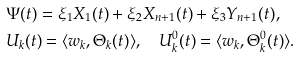Convert formula to latex. <formula><loc_0><loc_0><loc_500><loc_500>& \Psi ( t ) = \xi _ { 1 } X _ { 1 } ( t ) + \xi _ { 2 } X _ { n + 1 } ( t ) + \xi _ { 3 } Y _ { n + 1 } ( t ) , \\ & U _ { k } ( t ) = \langle w _ { k } , \Theta _ { k } ( t ) \rangle , \quad U ^ { 0 } _ { k } ( t ) = \langle w _ { k } , \Theta ^ { 0 } _ { k } ( t ) \rangle .</formula> 